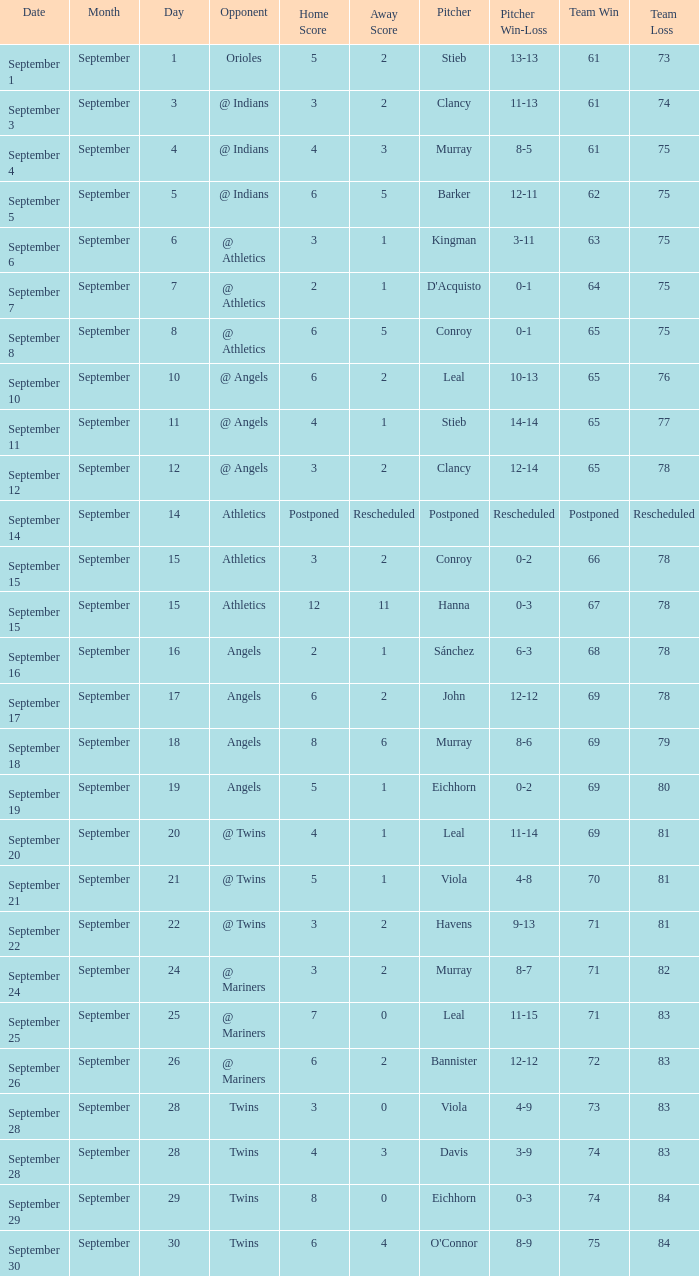What is the date associated with the record of 74-84? September 29. 